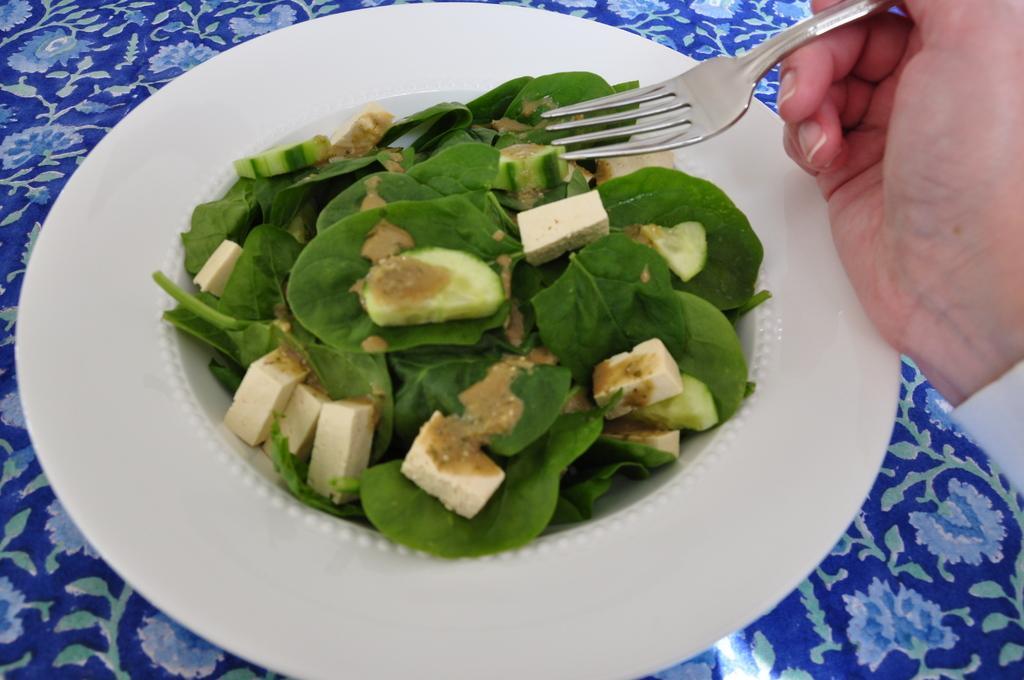Can you describe this image briefly? In this image there is a plate on the table. There is some food and leafy vegetables are on the plate. Right side a person's hand is visible. He is holding a fork. 